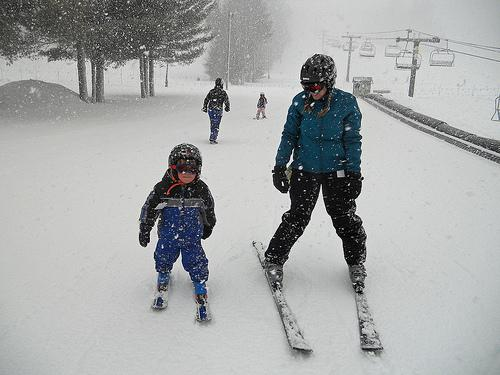Question: where is this picture taken?
Choices:
A. At a ski slope.
B. On the mountain.
C. By the river.
D. Near the valley.
Answer with the letter. Answer: A Question: what are the people in the picture doing?
Choices:
A. Running.
B. Skateboarding.
C. Surfing.
D. Skiing.
Answer with the letter. Answer: D Question: who is in the foreground of the picture?
Choices:
A. A man and his family.
B. A mother.
C. A woman and a little boy.
D. A wife and husband.
Answer with the letter. Answer: C Question: what are the people wearing?
Choices:
A. Coats.
B. Shirts.
C. Basketball uniforms.
D. Ski suits.
Answer with the letter. Answer: D Question: why are the people wearing goggles?
Choices:
A. To protect their eyes.
B. To block the sun.
C. To keep out water.
D. To keep out wind.
Answer with the letter. Answer: A 